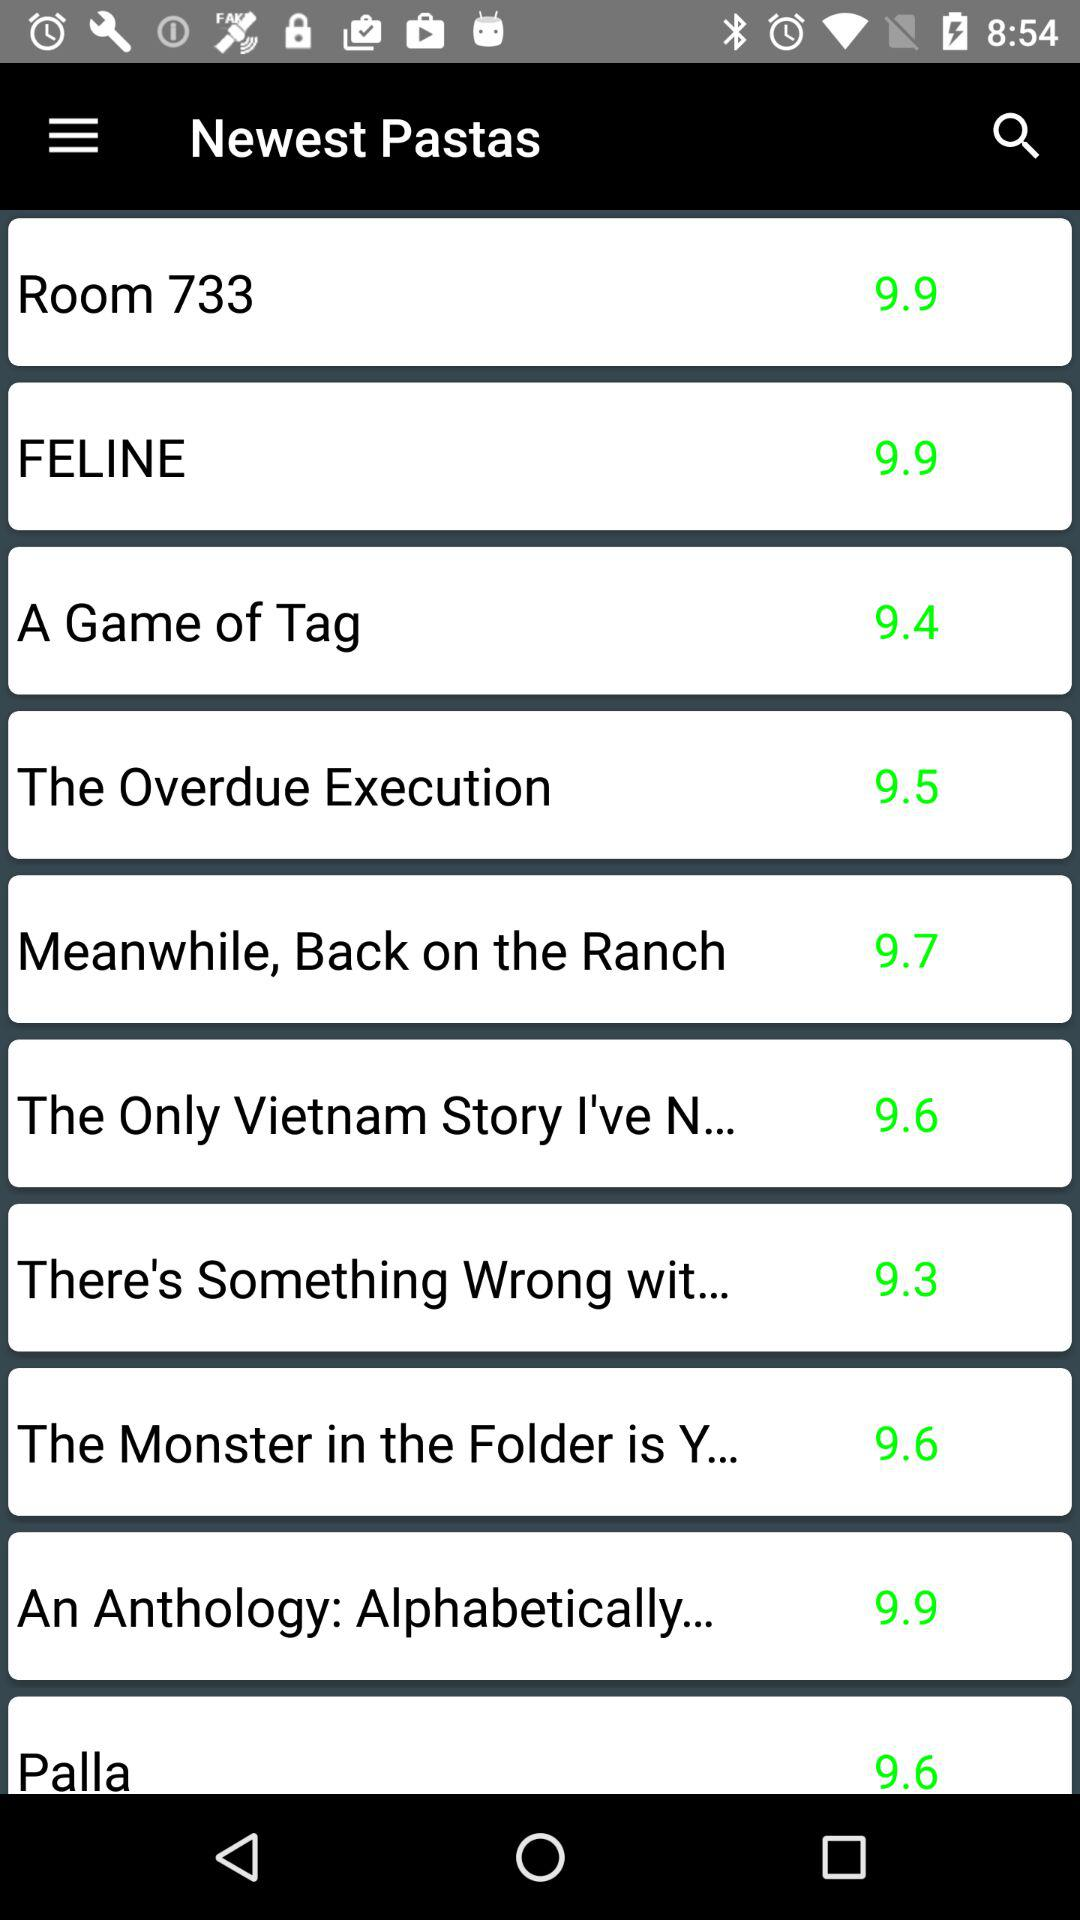What are the different available varieties of pasta? The available varieties are "Room 733", "FELINE", "A Game of Tag", "The Overdue Execution", "Meanwhile, Back on the Ranch", "The Only Vietnam Story I've N...", "There's Something Wrong wit...", "The Monster in the Folder is Y...", "An Anthology: Alphabetically..." and "Palla". 